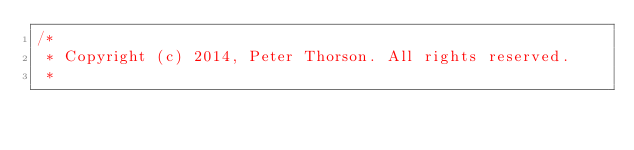<code> <loc_0><loc_0><loc_500><loc_500><_C++_>/*
 * Copyright (c) 2014, Peter Thorson. All rights reserved.
 *</code> 